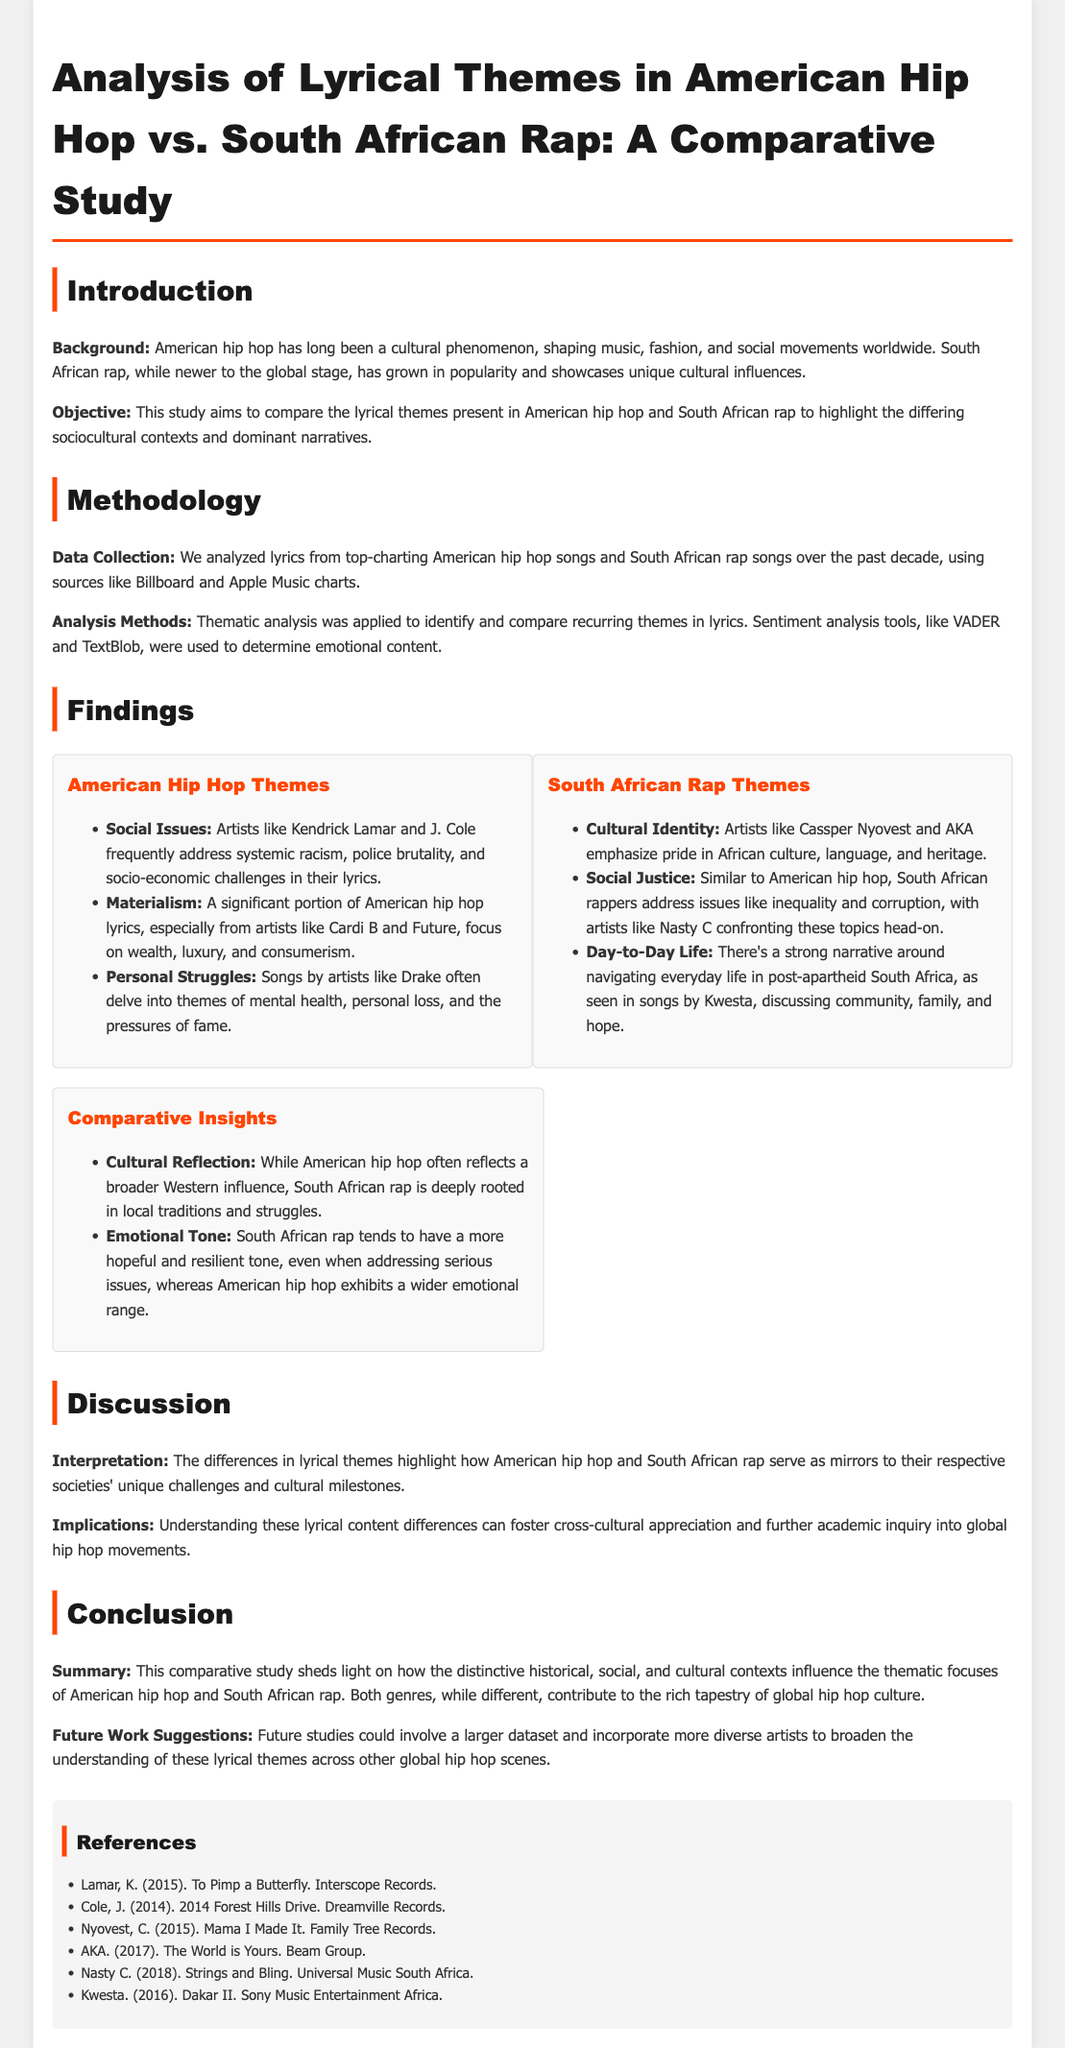what is the purpose of this study? The purpose of the study is to compare the lyrical themes present in American hip hop and South African rap.
Answer: Compare lyrical themes who are two prominent American hip hop artists mentioned? Two prominent American hip hop artists mentioned are Kendrick Lamar and J. Cole.
Answer: Kendrick Lamar and J. Cole what element distinguishes South African rap? South African rap is distinguished by its emphasis on cultural identity.
Answer: Cultural identity which year was "To Pimp a Butterfly" released? "To Pimp a Butterfly" was released in 2015.
Answer: 2015 what analytical method was used in the study? The method used in the study is thematic analysis.
Answer: Thematic analysis how do South African rap and American hip hop differ in emotional tone? South African rap tends to have a more hopeful and resilient tone.
Answer: More hopeful and resilient tone which theme is shared by both American hip hop and South African rap? Both genres address social issues like inequality and corruption.
Answer: Social issues who are two South African rap artists highlighted in the findings? Two highlighted South African rap artists are Cassper Nyovest and AKA.
Answer: Cassper Nyovest and AKA what does the study suggest for future research? The study suggests incorporating a larger dataset and more diverse artists for future research.
Answer: Larger dataset and diverse artists 